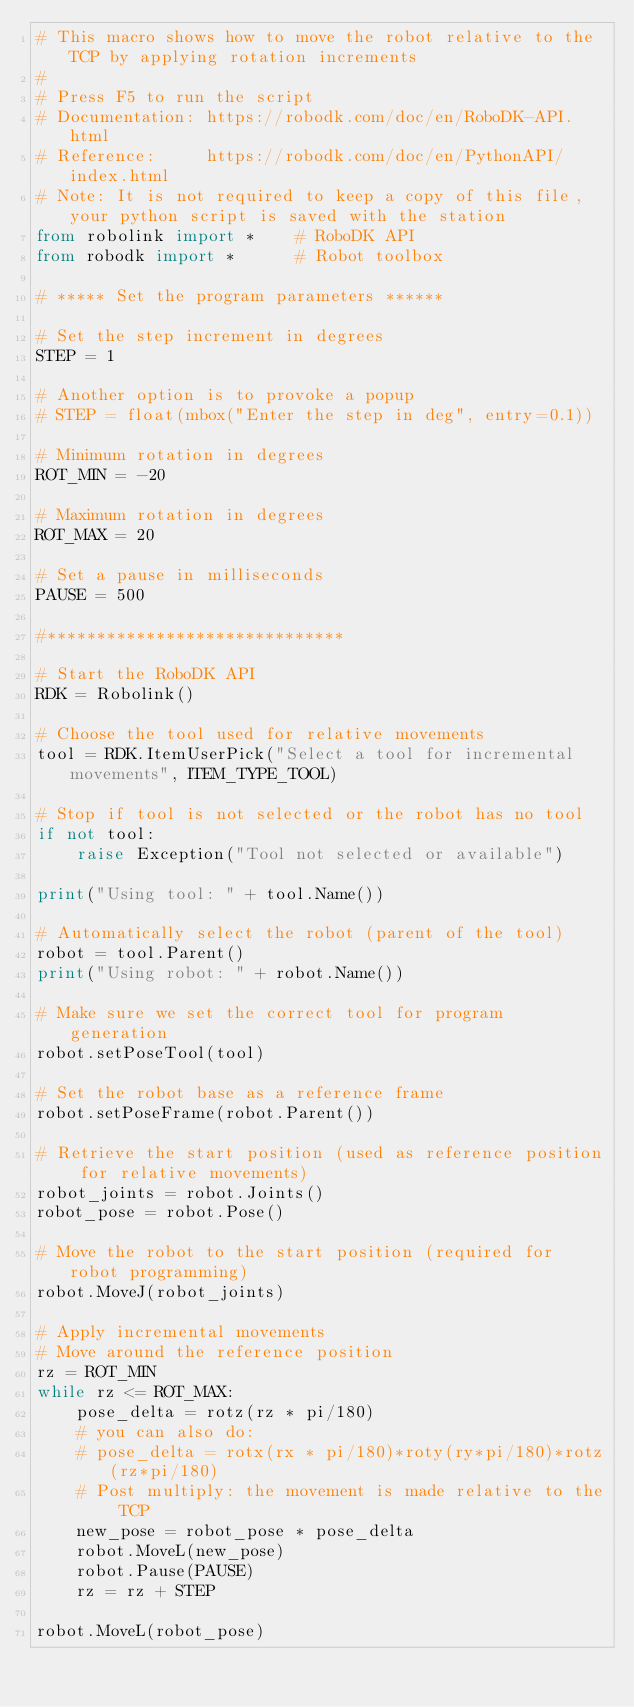<code> <loc_0><loc_0><loc_500><loc_500><_Python_># This macro shows how to move the robot relative to the TCP by applying rotation increments
#
# Press F5 to run the script
# Documentation: https://robodk.com/doc/en/RoboDK-API.html
# Reference:     https://robodk.com/doc/en/PythonAPI/index.html
# Note: It is not required to keep a copy of this file, your python script is saved with the station
from robolink import *    # RoboDK API
from robodk import *      # Robot toolbox

# ***** Set the program parameters ******

# Set the step increment in degrees
STEP = 1 

# Another option is to provoke a popup
# STEP = float(mbox("Enter the step in deg", entry=0.1)) 

# Minimum rotation in degrees
ROT_MIN = -20 

# Maximum rotation in degrees
ROT_MAX = 20 

# Set a pause in milliseconds
PAUSE = 500

#******************************

# Start the RoboDK API
RDK = Robolink()          

# Choose the tool used for relative movements
tool = RDK.ItemUserPick("Select a tool for incremental movements", ITEM_TYPE_TOOL)

# Stop if tool is not selected or the robot has no tool
if not tool:
    raise Exception("Tool not selected or available")

print("Using tool: " + tool.Name())

# Automatically select the robot (parent of the tool)
robot = tool.Parent()
print("Using robot: " + robot.Name())

# Make sure we set the correct tool for program generation
robot.setPoseTool(tool)

# Set the robot base as a reference frame
robot.setPoseFrame(robot.Parent())

# Retrieve the start position (used as reference position for relative movements)
robot_joints = robot.Joints()
robot_pose = robot.Pose()

# Move the robot to the start position (required for robot programming)
robot.MoveJ(robot_joints)

# Apply incremental movements
# Move around the reference position
rz = ROT_MIN
while rz <= ROT_MAX:
    pose_delta = rotz(rz * pi/180)
    # you can also do:
    # pose_delta = rotx(rx * pi/180)*roty(ry*pi/180)*rotz(rz*pi/180)
    # Post multiply: the movement is made relative to the TCP
    new_pose = robot_pose * pose_delta
    robot.MoveL(new_pose)
    robot.Pause(PAUSE)
    rz = rz + STEP

robot.MoveL(robot_pose)

</code> 